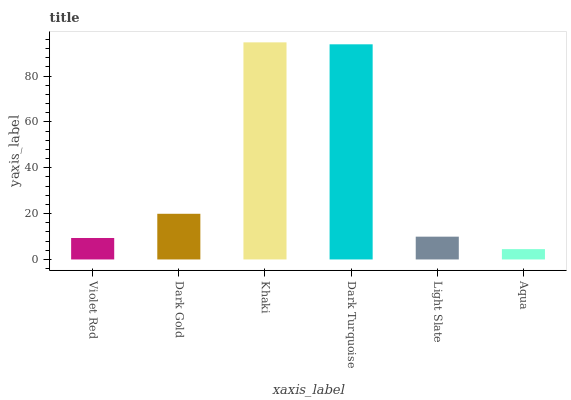Is Aqua the minimum?
Answer yes or no. Yes. Is Khaki the maximum?
Answer yes or no. Yes. Is Dark Gold the minimum?
Answer yes or no. No. Is Dark Gold the maximum?
Answer yes or no. No. Is Dark Gold greater than Violet Red?
Answer yes or no. Yes. Is Violet Red less than Dark Gold?
Answer yes or no. Yes. Is Violet Red greater than Dark Gold?
Answer yes or no. No. Is Dark Gold less than Violet Red?
Answer yes or no. No. Is Dark Gold the high median?
Answer yes or no. Yes. Is Light Slate the low median?
Answer yes or no. Yes. Is Violet Red the high median?
Answer yes or no. No. Is Violet Red the low median?
Answer yes or no. No. 